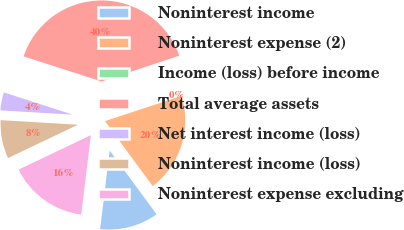Convert chart. <chart><loc_0><loc_0><loc_500><loc_500><pie_chart><fcel>Noninterest income<fcel>Noninterest expense (2)<fcel>Income (loss) before income<fcel>Total average assets<fcel>Net interest income (loss)<fcel>Noninterest income (loss)<fcel>Noninterest expense excluding<nl><fcel>12.01%<fcel>19.98%<fcel>0.04%<fcel>39.93%<fcel>4.03%<fcel>8.02%<fcel>16.0%<nl></chart> 